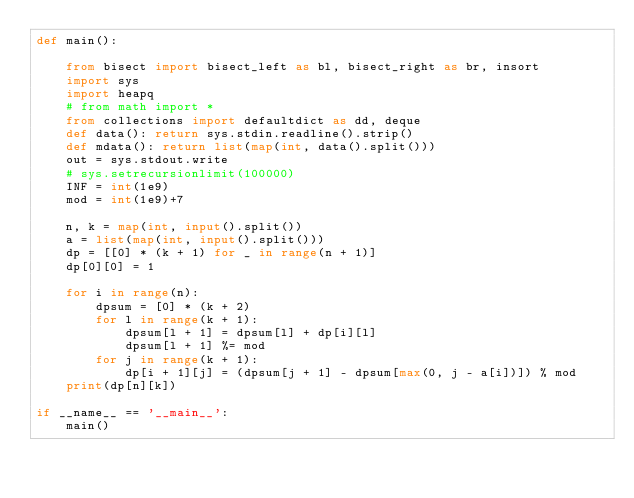Convert code to text. <code><loc_0><loc_0><loc_500><loc_500><_Python_>def main():

    from bisect import bisect_left as bl, bisect_right as br, insort
    import sys
    import heapq
    # from math import *
    from collections import defaultdict as dd, deque
    def data(): return sys.stdin.readline().strip()
    def mdata(): return list(map(int, data().split()))
    out = sys.stdout.write
    # sys.setrecursionlimit(100000)
    INF = int(1e9)
    mod = int(1e9)+7

    n, k = map(int, input().split())
    a = list(map(int, input().split()))
    dp = [[0] * (k + 1) for _ in range(n + 1)]
    dp[0][0] = 1

    for i in range(n):
        dpsum = [0] * (k + 2)
        for l in range(k + 1):
            dpsum[l + 1] = dpsum[l] + dp[i][l]
            dpsum[l + 1] %= mod
        for j in range(k + 1):
            dp[i + 1][j] = (dpsum[j + 1] - dpsum[max(0, j - a[i])]) % mod
    print(dp[n][k])
    
if __name__ == '__main__':
    main()</code> 